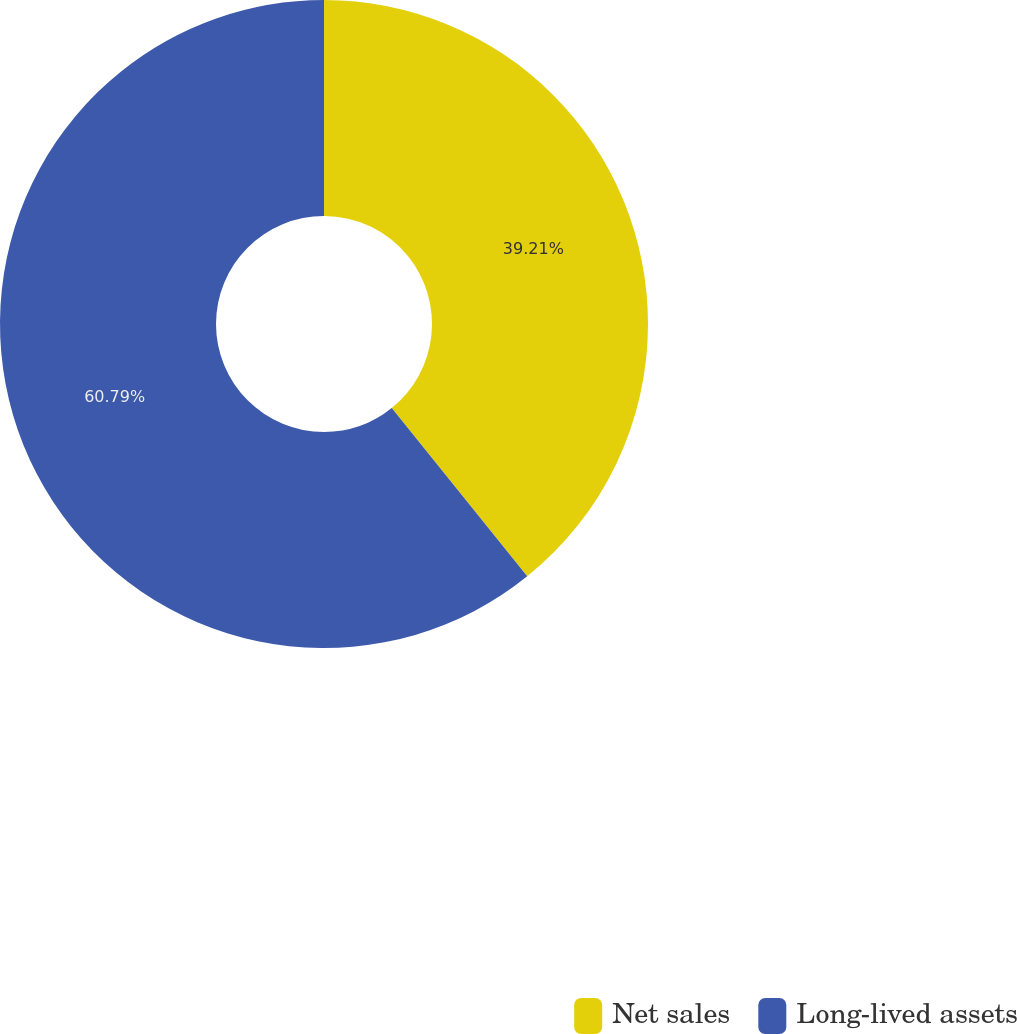Convert chart. <chart><loc_0><loc_0><loc_500><loc_500><pie_chart><fcel>Net sales<fcel>Long-lived assets<nl><fcel>39.21%<fcel>60.79%<nl></chart> 